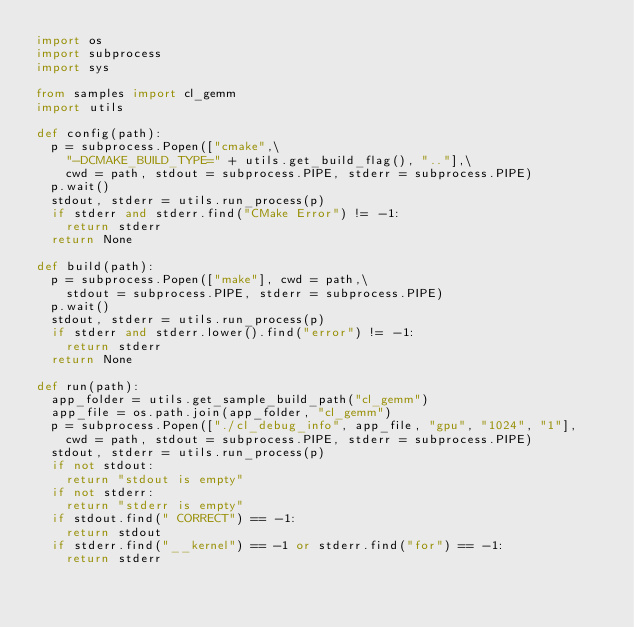<code> <loc_0><loc_0><loc_500><loc_500><_Python_>import os
import subprocess
import sys

from samples import cl_gemm
import utils

def config(path):
  p = subprocess.Popen(["cmake",\
    "-DCMAKE_BUILD_TYPE=" + utils.get_build_flag(), ".."],\
    cwd = path, stdout = subprocess.PIPE, stderr = subprocess.PIPE)
  p.wait()
  stdout, stderr = utils.run_process(p)
  if stderr and stderr.find("CMake Error") != -1:
    return stderr
  return None

def build(path):
  p = subprocess.Popen(["make"], cwd = path,\
    stdout = subprocess.PIPE, stderr = subprocess.PIPE)
  p.wait()
  stdout, stderr = utils.run_process(p)
  if stderr and stderr.lower().find("error") != -1:
    return stderr
  return None

def run(path):
  app_folder = utils.get_sample_build_path("cl_gemm")
  app_file = os.path.join(app_folder, "cl_gemm")
  p = subprocess.Popen(["./cl_debug_info", app_file, "gpu", "1024", "1"],
    cwd = path, stdout = subprocess.PIPE, stderr = subprocess.PIPE)
  stdout, stderr = utils.run_process(p)
  if not stdout:
    return "stdout is empty"
  if not stderr:
    return "stderr is empty"
  if stdout.find(" CORRECT") == -1:
    return stdout
  if stderr.find("__kernel") == -1 or stderr.find("for") == -1:
    return stderr</code> 